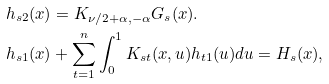<formula> <loc_0><loc_0><loc_500><loc_500>& h _ { s 2 } ( x ) = K _ { \nu / 2 + \alpha , - \alpha } G _ { s } ( x ) . \\ & h _ { s 1 } ( x ) + \sum _ { t = 1 } ^ { n } \int ^ { 1 } _ { 0 } K _ { s t } ( x , u ) h _ { t 1 } ( u ) d u = H _ { s } ( x ) ,</formula> 